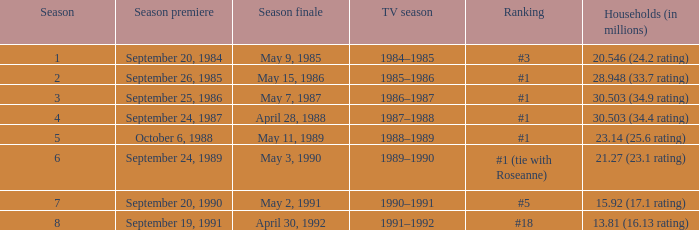Which television series season features a season under 8, and a household (in millions) of 1 1990–1991. 